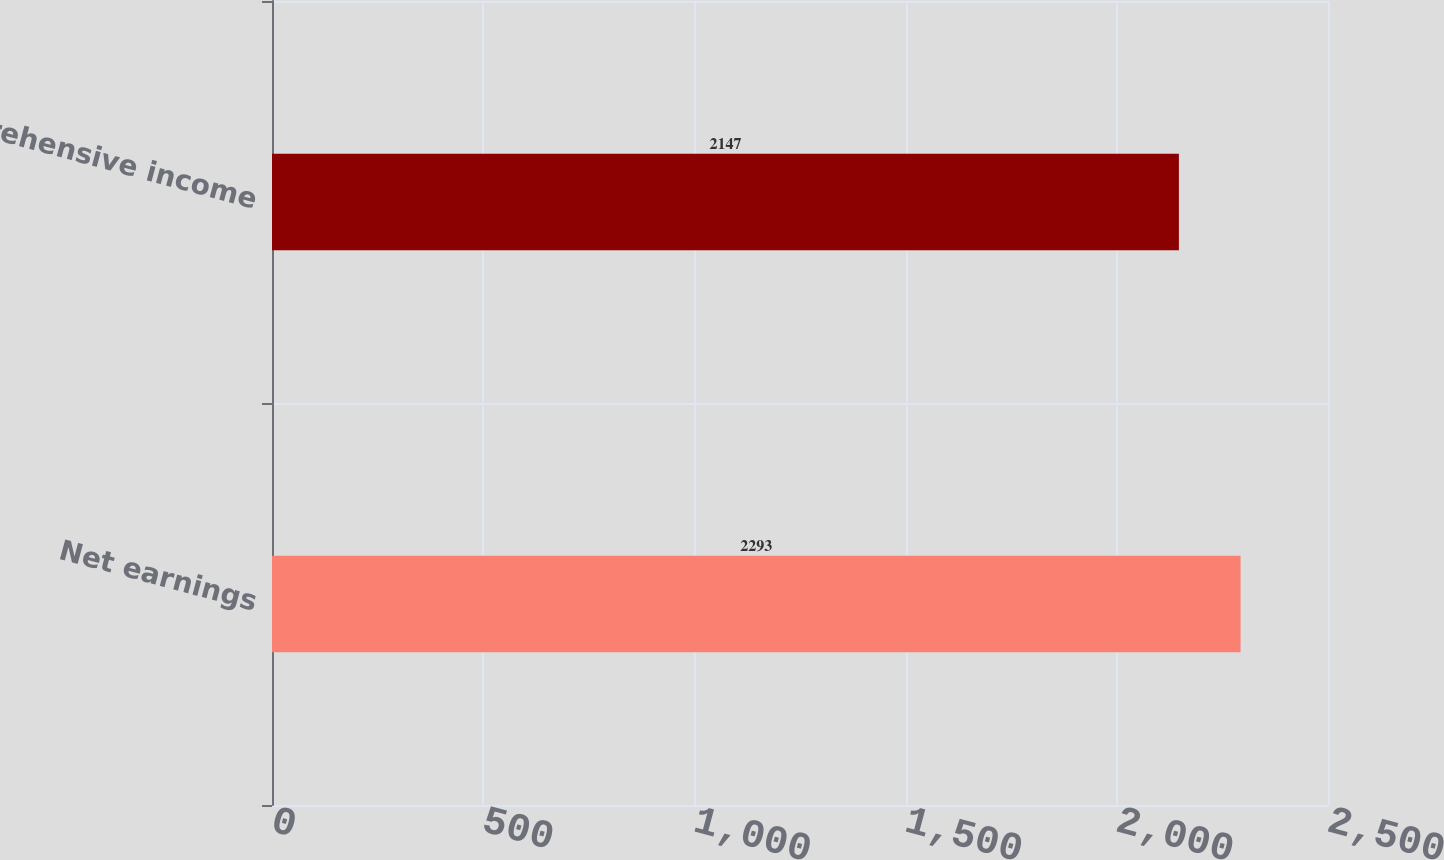<chart> <loc_0><loc_0><loc_500><loc_500><bar_chart><fcel>Net earnings<fcel>Comprehensive income<nl><fcel>2293<fcel>2147<nl></chart> 